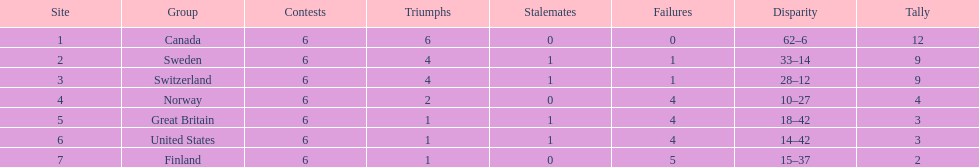What is the total number of teams to have 4 total wins? 2. Could you help me parse every detail presented in this table? {'header': ['Site', 'Group', 'Contests', 'Triumphs', 'Stalemates', 'Failures', 'Disparity', 'Tally'], 'rows': [['1', 'Canada', '6', '6', '0', '0', '62–6', '12'], ['2', 'Sweden', '6', '4', '1', '1', '33–14', '9'], ['3', 'Switzerland', '6', '4', '1', '1', '28–12', '9'], ['4', 'Norway', '6', '2', '0', '4', '10–27', '4'], ['5', 'Great Britain', '6', '1', '1', '4', '18–42', '3'], ['6', 'United States', '6', '1', '1', '4', '14–42', '3'], ['7', 'Finland', '6', '1', '0', '5', '15–37', '2']]} 